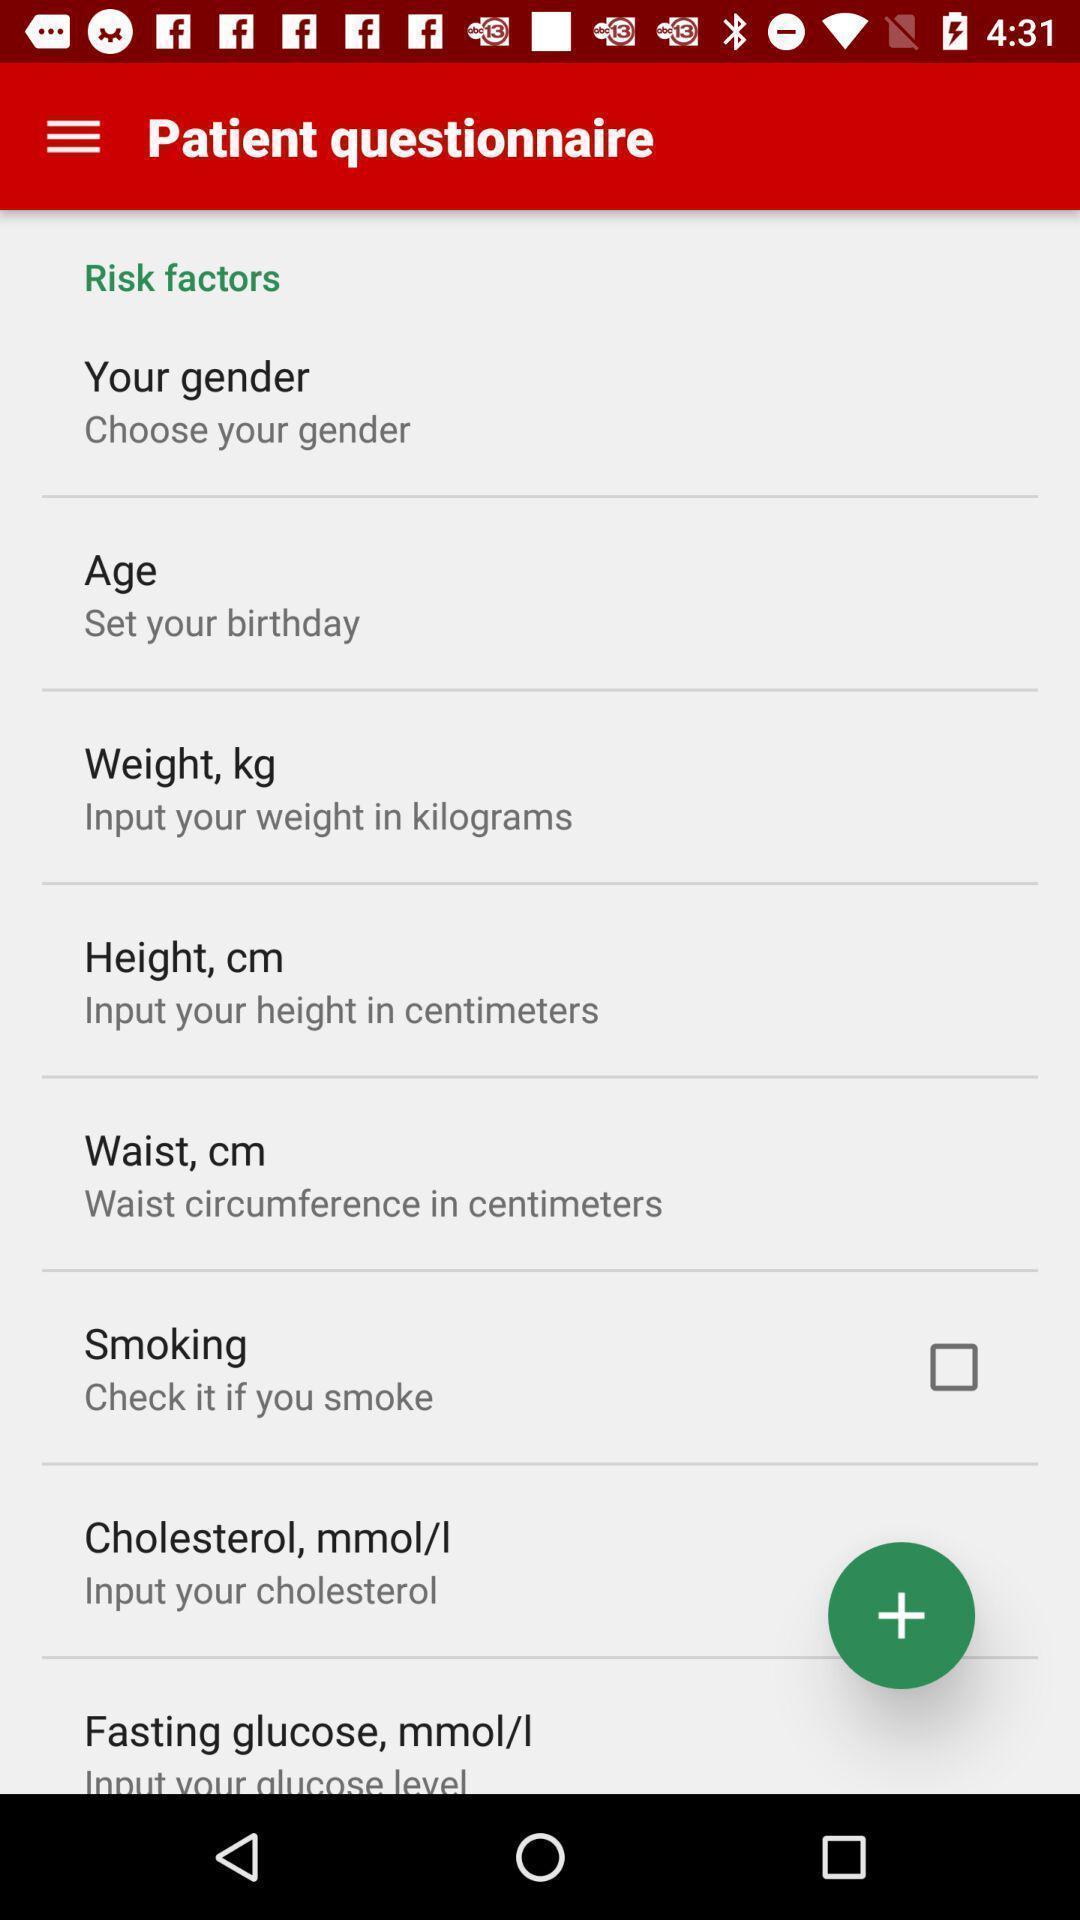Provide a detailed account of this screenshot. Personal profile details to enter in the application. 